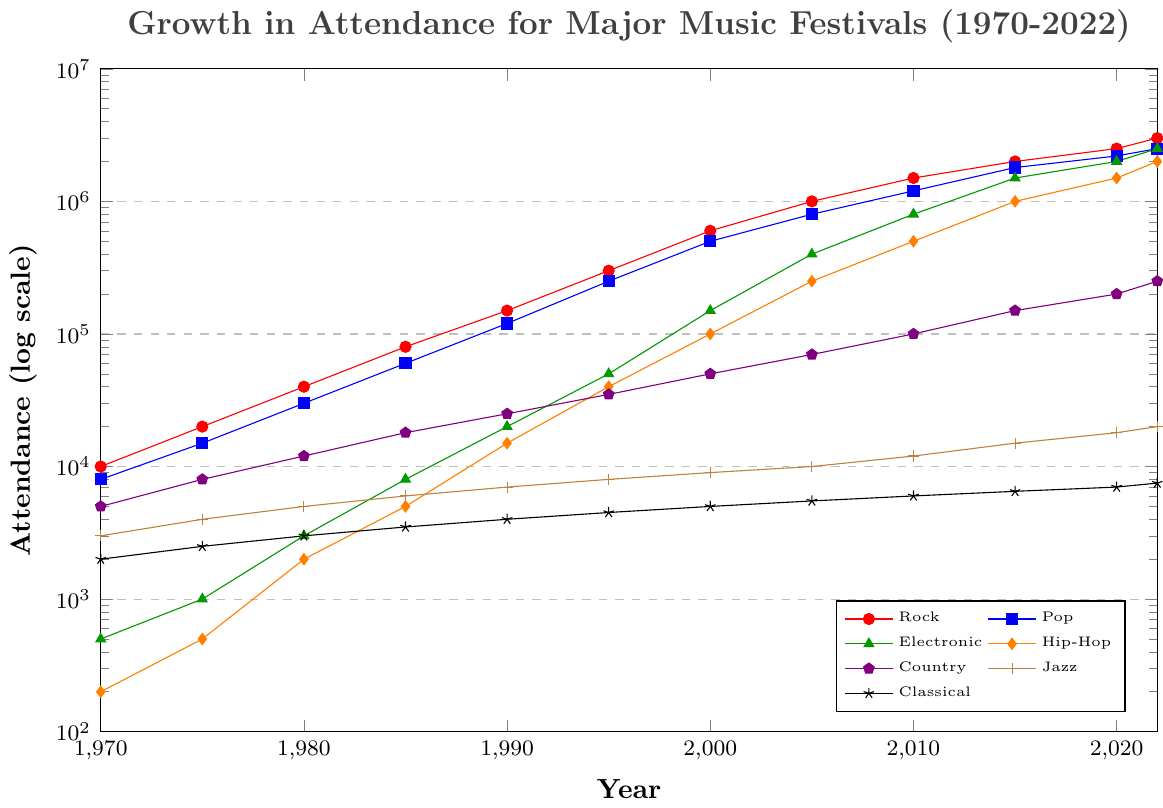What is the genre with the highest attendance in 2022? To find the genre with the highest attendance in 2022, locate the furthest point to the top on the vertical axis (log scale) for the year 2022; the red curve representing Rock peaks the highest at approximately 3,000,000.
Answer: Rock Which genre had the smallest growth in attendance from 1970 to 2022? To determine the smallest growth, subtract the 1970 value from the 2022 value for each genre and compare. Jazz grows from 3,000 to 20,000 (increase of 17,000), and Classical grows from 2,000 to 7,500 (increase of 5,500). Classical has the smallest growth.
Answer: Classical Between Electronic and Hip-Hop, which genre had a higher attendance in 2000, and by how much? Check the coordinates for the year 2000 for both genres. Electronic had 150,000 attendees, and Hip-Hop had 100,000. The difference in attendance is 150,000 - 100,000 = 50,000.
Answer: Electronic by 50,000 Which genre had the most consistent growth with no significant dips or spikes? By visually examining the plotted lines, Jazz (brown line) shows the most consistent and gradual increase in attendance over the years without significant spikes or dips.
Answer: Jazz What was the attendance growth rate for Pop music from 1990 to 2000? Attendance for Pop in 1990 was 120,000 and in 2000 was 500,000. The growth rate is calculated as (500,000 - 120,000) / 120,000 = 3.1667 or 316.67%.
Answer: 316.67% Which genre showed exponential growth beginning after 2000? By looking at lines with steeper slopes starting after 2000, Electronic (green line) shows exponential growth, accelerating sharply from 150,000 attendees in 2000 to 2,500,000 in 2022.
Answer: Electronic Compare the attendance growth of Rock from 1980 to 2010 with that of Country in the same period. Which grew more and by how much? Rock grew from 40,000 in 1980 to 1,500,000 in 2010, which is an increase of 1,460,000. Country grew from 12,000 to 100,000, an increase of 88,000. The difference is 1,460,000 - 88,000 = 1,372,000.
Answer: Rock by 1,372,000 How many genres had an attendance of over 1,000,000 in 2022? Count the number of lines crossing the 1,000,000 mark in 2022. Rock, Pop, Electronic, and Hip-Hop all exceed 1,000,000 attendees.
Answer: 4 In which year did Jazz first exceed 10,000 attendees? Following the brown line for Jazz, it first crosses the 10,000 mark in 2005.
Answer: 2005 